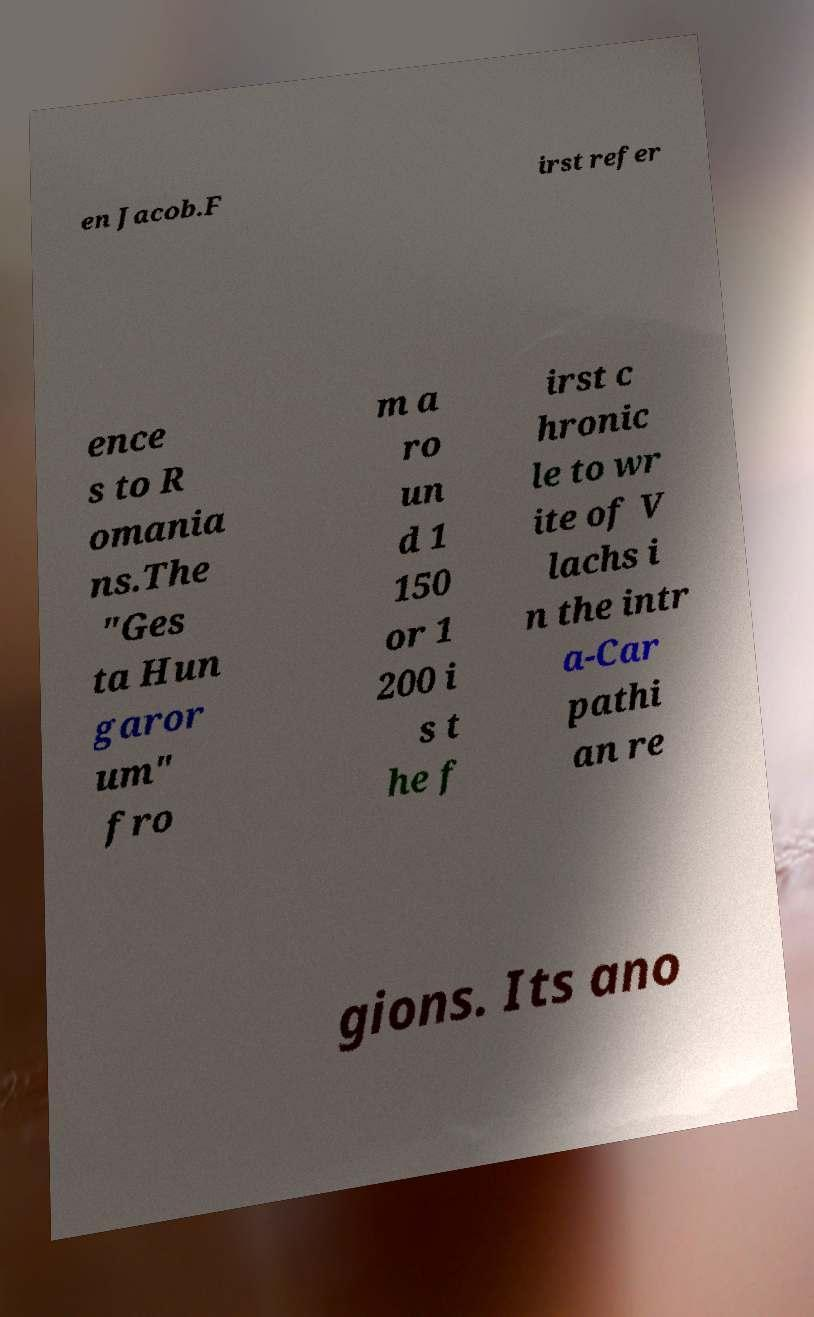Please identify and transcribe the text found in this image. en Jacob.F irst refer ence s to R omania ns.The "Ges ta Hun garor um" fro m a ro un d 1 150 or 1 200 i s t he f irst c hronic le to wr ite of V lachs i n the intr a-Car pathi an re gions. Its ano 